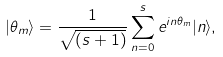Convert formula to latex. <formula><loc_0><loc_0><loc_500><loc_500>| \theta _ { m } \rangle = \frac { 1 } { \sqrt { ( s + 1 ) } } \sum _ { n = 0 } ^ { s } e ^ { i n \theta _ { m } } | n \rangle ,</formula> 